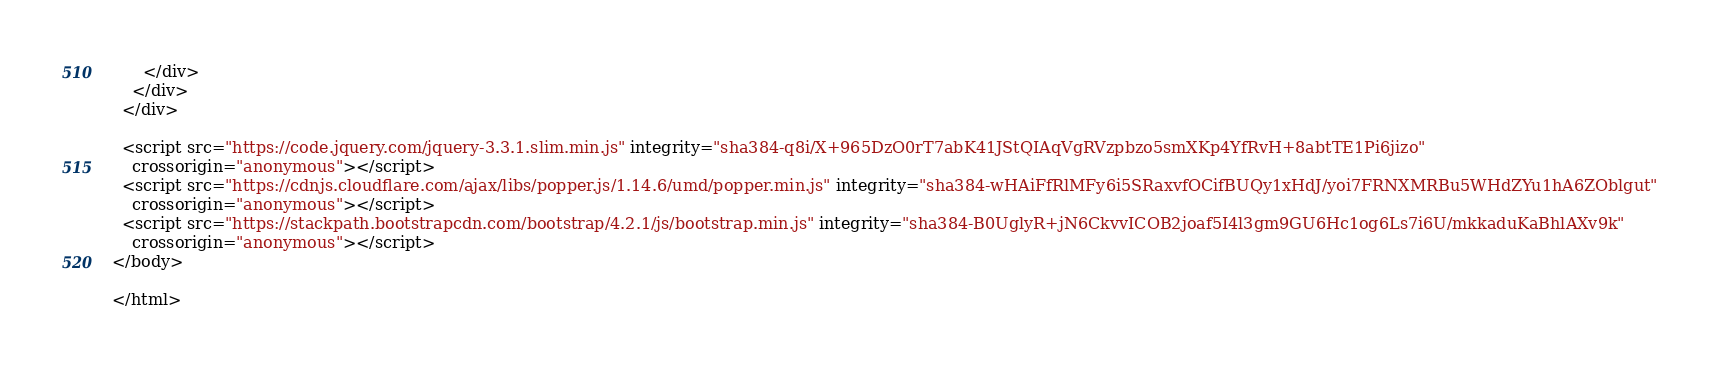Convert code to text. <code><loc_0><loc_0><loc_500><loc_500><_HTML_>      </div>
    </div>
  </div>

  <script src="https://code.jquery.com/jquery-3.3.1.slim.min.js" integrity="sha384-q8i/X+965DzO0rT7abK41JStQIAqVgRVzpbzo5smXKp4YfRvH+8abtTE1Pi6jizo"
    crossorigin="anonymous"></script>
  <script src="https://cdnjs.cloudflare.com/ajax/libs/popper.js/1.14.6/umd/popper.min.js" integrity="sha384-wHAiFfRlMFy6i5SRaxvfOCifBUQy1xHdJ/yoi7FRNXMRBu5WHdZYu1hA6ZOblgut"
    crossorigin="anonymous"></script>
  <script src="https://stackpath.bootstrapcdn.com/bootstrap/4.2.1/js/bootstrap.min.js" integrity="sha384-B0UglyR+jN6CkvvICOB2joaf5I4l3gm9GU6Hc1og6Ls7i6U/mkkaduKaBhlAXv9k"
    crossorigin="anonymous"></script>
</body>

</html></code> 